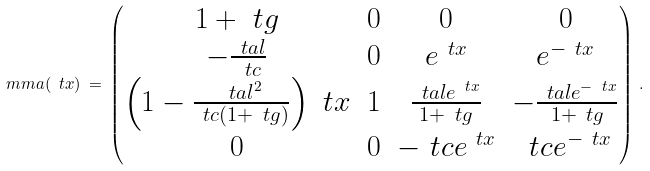<formula> <loc_0><loc_0><loc_500><loc_500>\ m m a ( \ t x ) \, = \, \begin{pmatrix} 1 + \ t g & 0 & 0 & 0 \\ - \frac { \ t a l } { \ t c } & 0 & e ^ { \ t x } & e ^ { - \ t x } \\ \left ( 1 - \frac { \ t a l ^ { 2 } } { \ t c ( 1 + \ t g ) } \right ) \ t x & 1 & \frac { \ t a l e ^ { \ t x } } { 1 + \ t g } & - \frac { \ t a l e ^ { - \ t x } } { 1 + \ t g } \\ 0 & 0 & - \ t c e ^ { \ t x } & \ t c e ^ { - \ t x } \end{pmatrix} \, .</formula> 